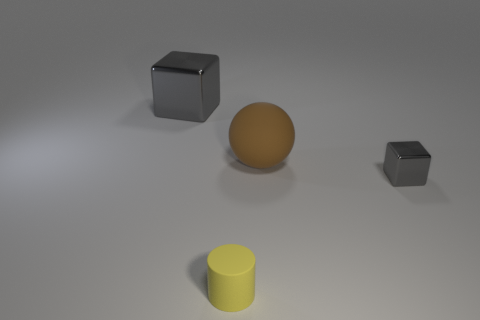Are there any other things that have the same shape as the small rubber thing?
Provide a succinct answer. No. There is another metallic thing that is the same shape as the large gray object; what color is it?
Your response must be concise. Gray. Do the brown matte object and the cylinder have the same size?
Ensure brevity in your answer.  No. What number of other things are the same size as the yellow cylinder?
Offer a very short reply. 1. What number of things are gray metal blocks behind the small metal thing or tiny metal things to the right of the brown rubber ball?
Ensure brevity in your answer.  2. There is a metal thing that is the same size as the rubber ball; what shape is it?
Provide a succinct answer. Cube. What size is the gray cube that is made of the same material as the small gray object?
Your answer should be compact. Large. Do the tiny gray metal object and the small yellow matte object have the same shape?
Provide a succinct answer. No. There is a thing that is the same size as the brown rubber sphere; what is its color?
Offer a terse response. Gray. What is the size of the other object that is the same shape as the small metal thing?
Offer a terse response. Large. 